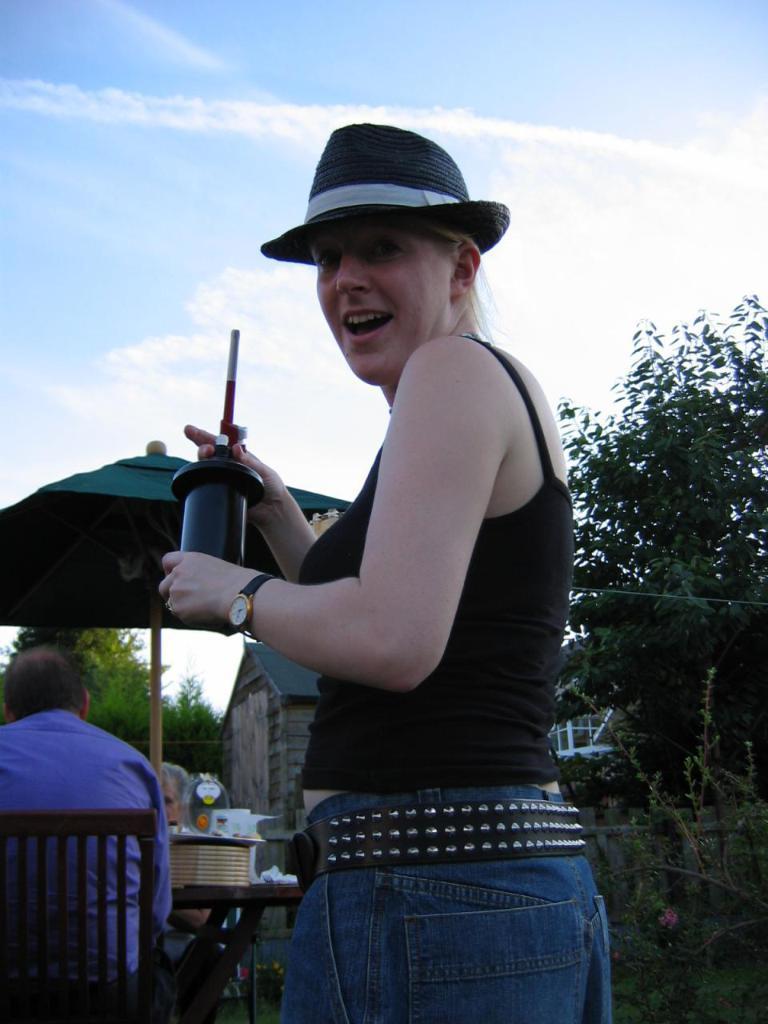Describe this image in one or two sentences. This is the woman standing and holding a black color object in her hands. She wore a hat, black top, trouser, belt and a wrist watch. I can see a person sitting on the chair. This looks like a table with few objects on it. I think this is the patio umbrella. In the background, I can see a wooden shelter, trees and plants. 